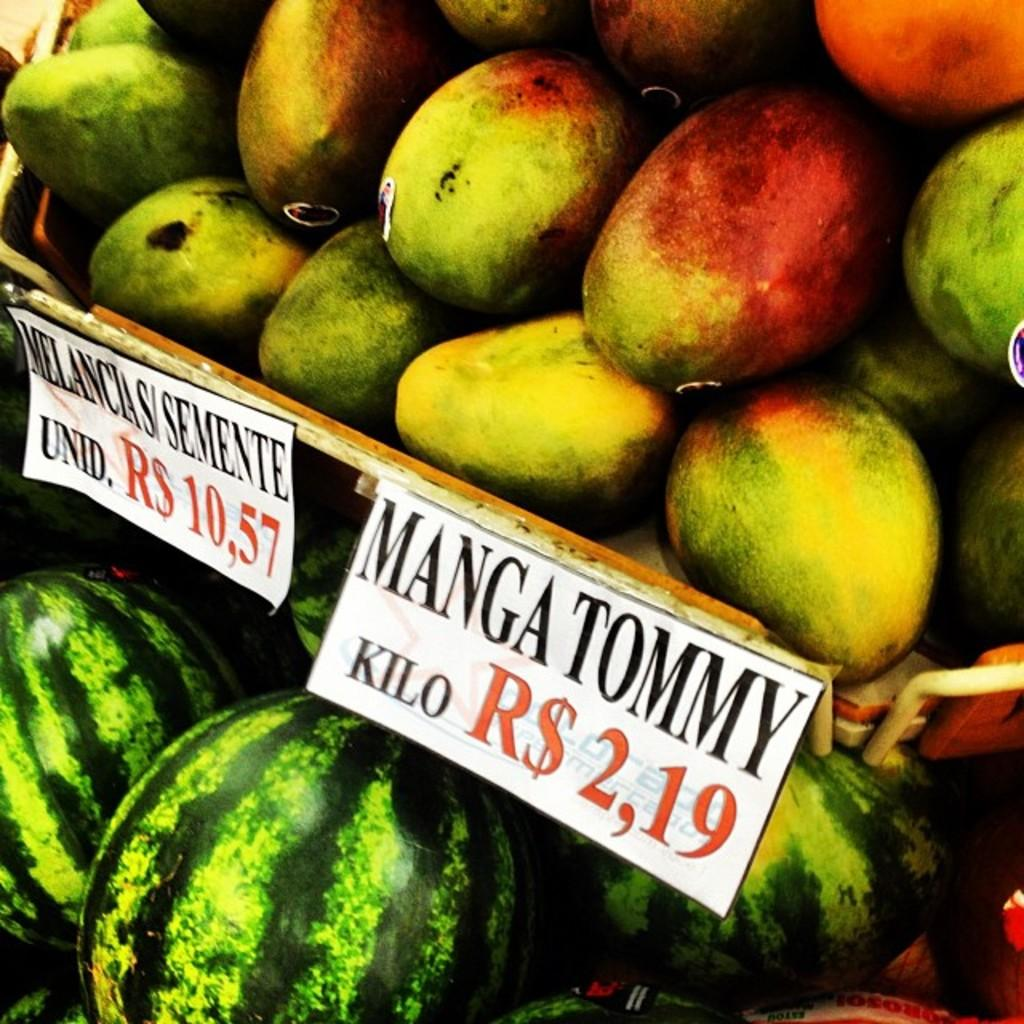What type of food items are present in the image? There are fruits in the image. Where are the fruits placed in the image? The fruits are kept on a shelf. Is there any additional information provided about the fruits? Yes, there is a tag visible in the image. What can be seen on the fruits themselves? Stickers are stuck to the fruits. How many toes can be seen on the fruits in the image? There are no toes visible on the fruits in the image, as fruits do not have toes. 